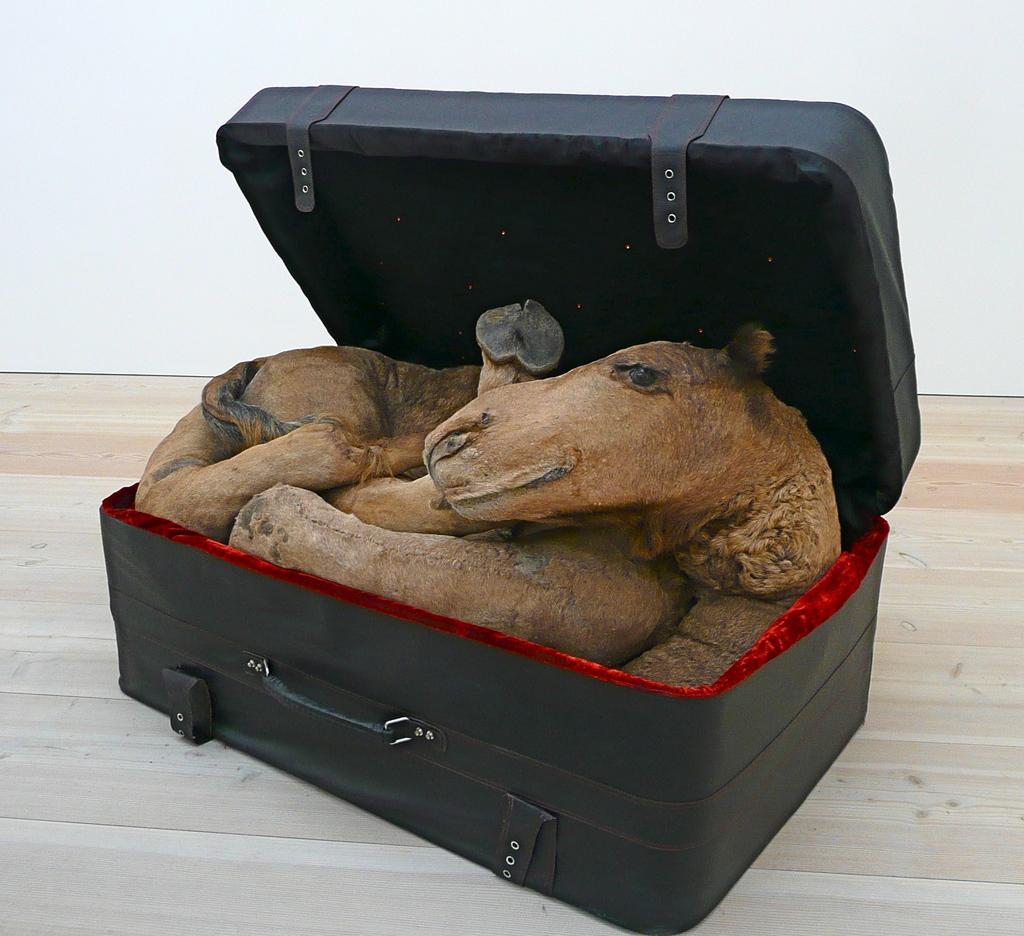Can you describe this image briefly? In this image I can see a black color suitcase. A toy is stuffed in his suitcase. 